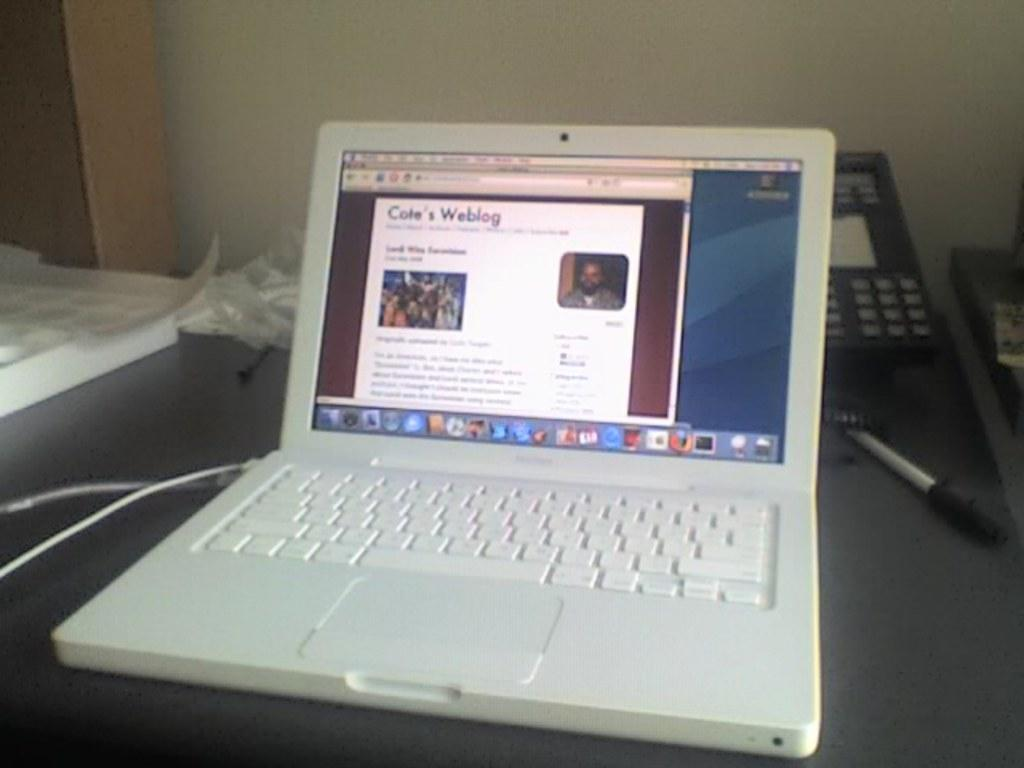<image>
Offer a succinct explanation of the picture presented. A Mac laptop showing Cote's Weblog web page. 